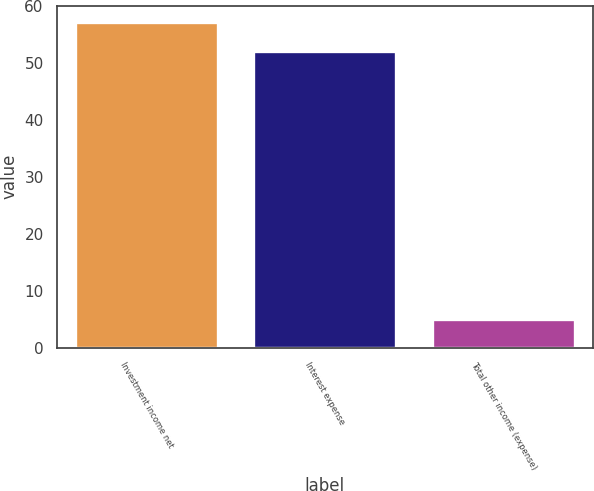<chart> <loc_0><loc_0><loc_500><loc_500><bar_chart><fcel>Investment income net<fcel>Interest expense<fcel>Total other income (expense)<nl><fcel>57.2<fcel>52<fcel>5<nl></chart> 